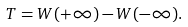<formula> <loc_0><loc_0><loc_500><loc_500>T = W ( + \infty ) - W ( - \infty ) .</formula> 